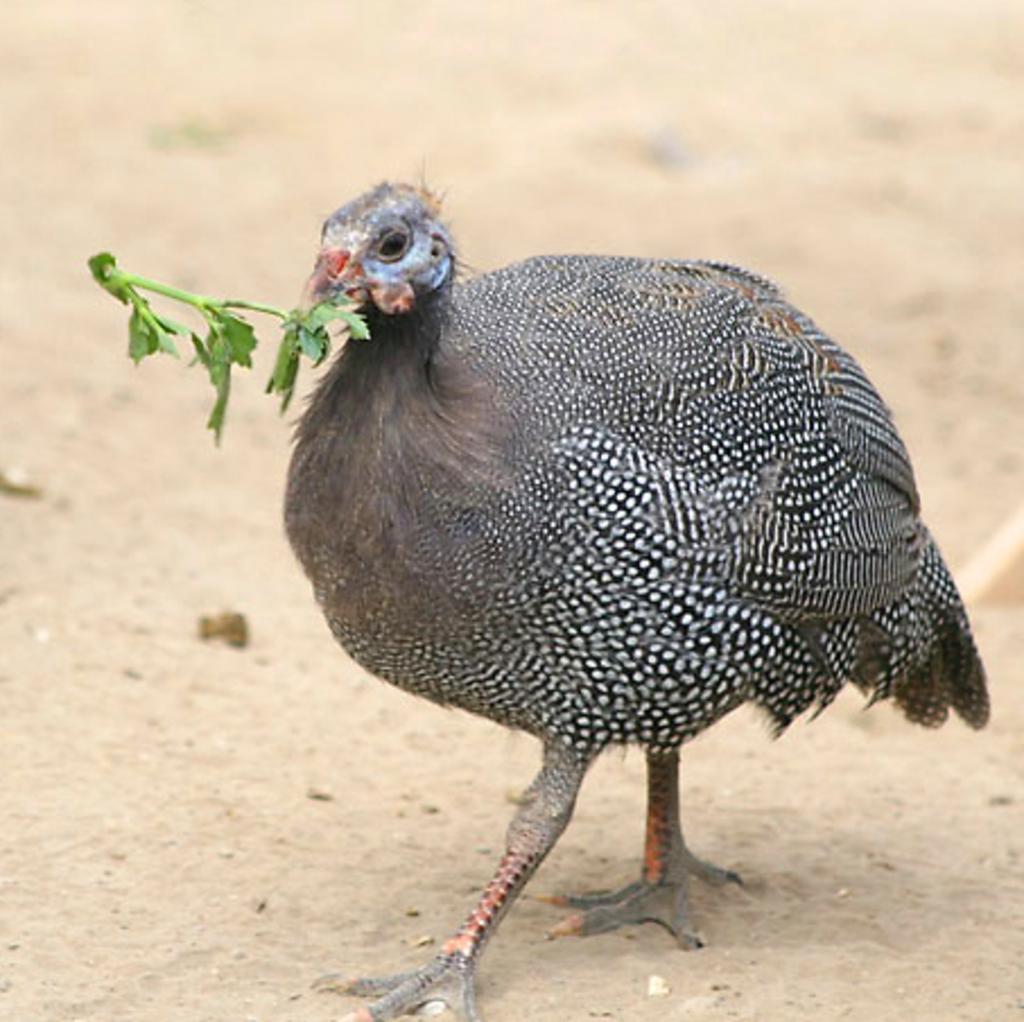Could you give a brief overview of what you see in this image? In this image there is a hen and there are leaves in the mouth of the hen. 